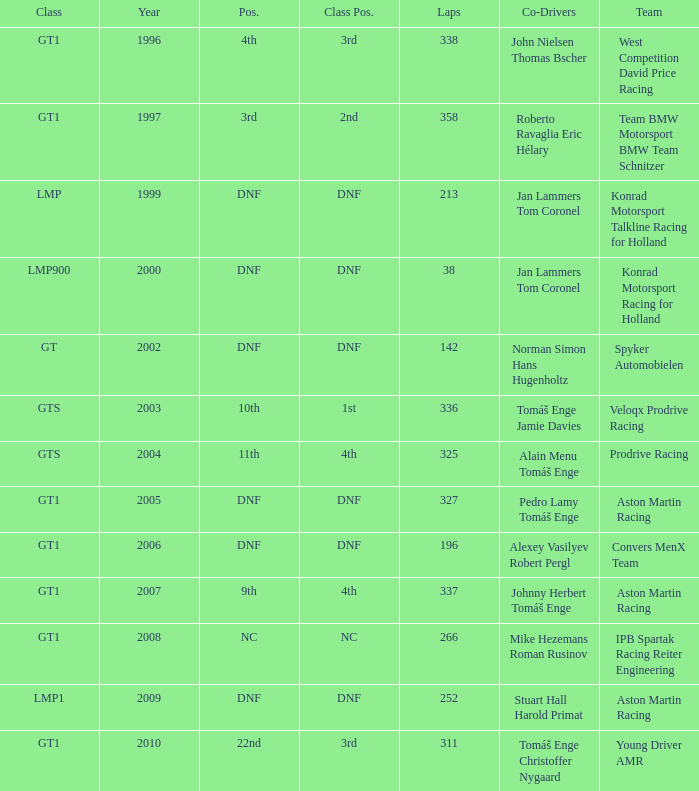What was the position in 1997? 3rd. 